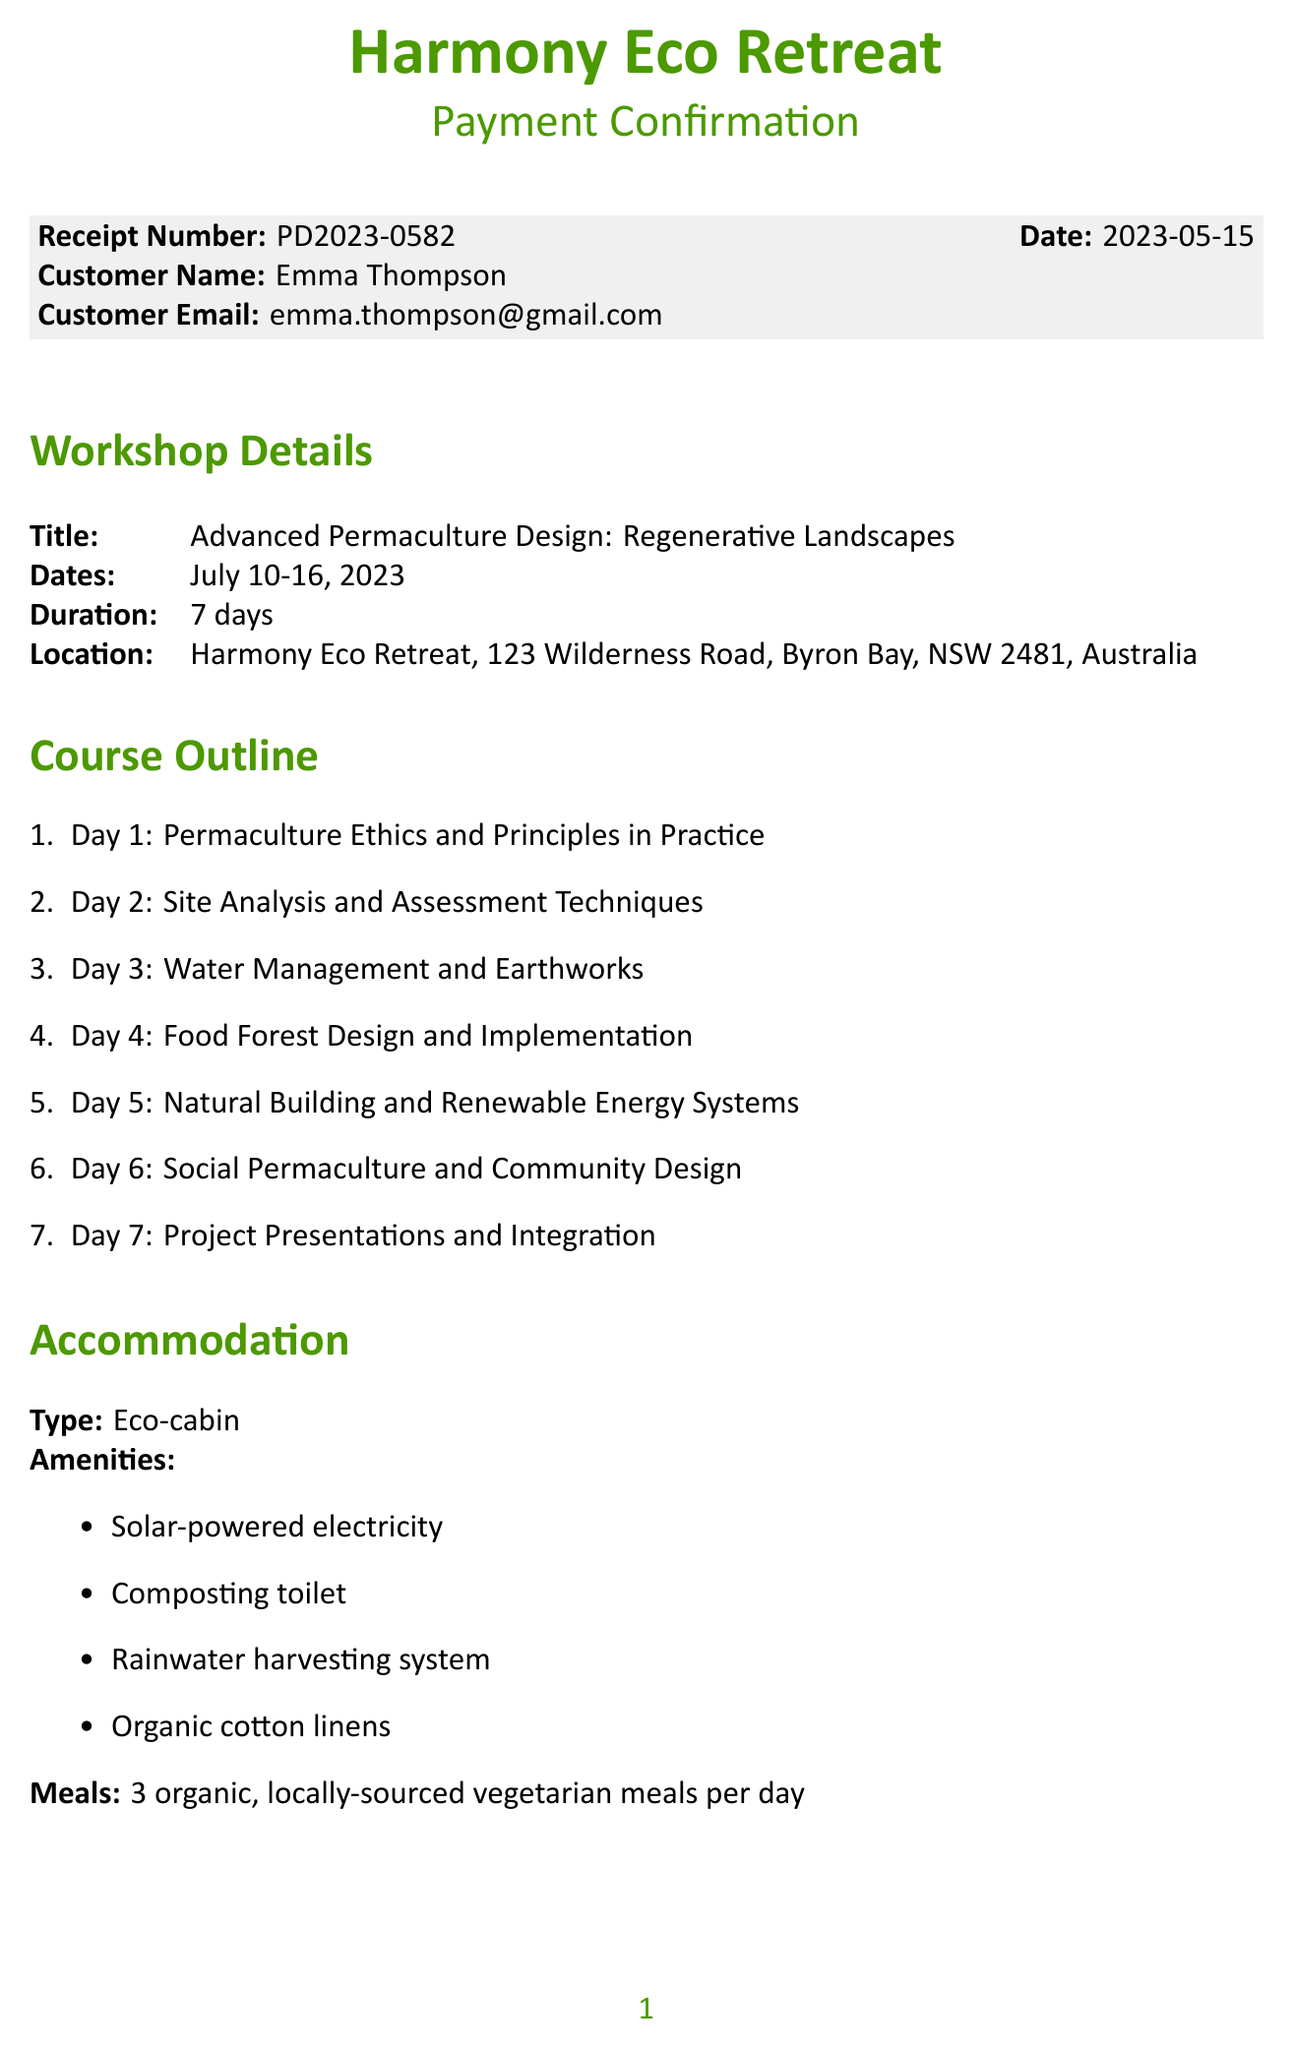what is the workshop title? The workshop title is specified in the workshop details section of the document.
Answer: Advanced Permaculture Design: Regenerative Landscapes what are the accommodation amenities? The accommodations listed amenities are found in the accommodation section of the document.
Answer: Solar-powered electricity, Composting toilet, Rainwater harvesting system, Organic cotton linens who is the contact person for the workshop? The contact person is mentioned under the contact information section in the document.
Answer: Olivia Green what is the total amount paid for the workshop? The total amount is provided under the payment details section of the document.
Answer: AUD 1,725.00 what is the cancellation policy? The cancellation policy is detailed in the additional information section and summarizes the refund terms.
Answer: Full refund available up to 30 days before the workshop start date how many days does the workshop last? The duration of the workshop is stated in the workshop details section of the document.
Answer: 7 days what date does the workshop start? The start date is specified in the workshop details section of the document.
Answer: July 10, 2023 what meals are provided during the workshop? The types of meals provided are detailed in the accommodation section of the document.
Answer: 3 organic, locally-sourced vegetarian meals per day what payment method was used? The payment method is specified in the payment details section of the document.
Answer: Credit Card (Visa ending in 4567) 